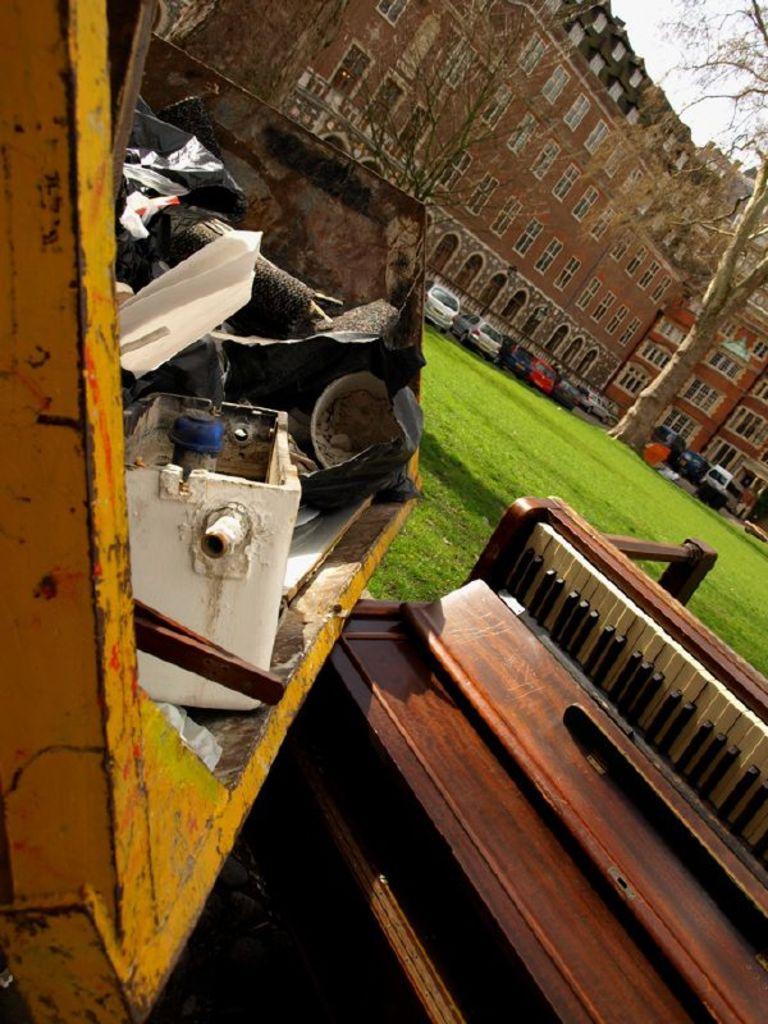Can you describe this image briefly? As we can see in the image there is a building, sky, tree, grass, few cars over here. In the front there is a dustbin and a musical keyboard. 